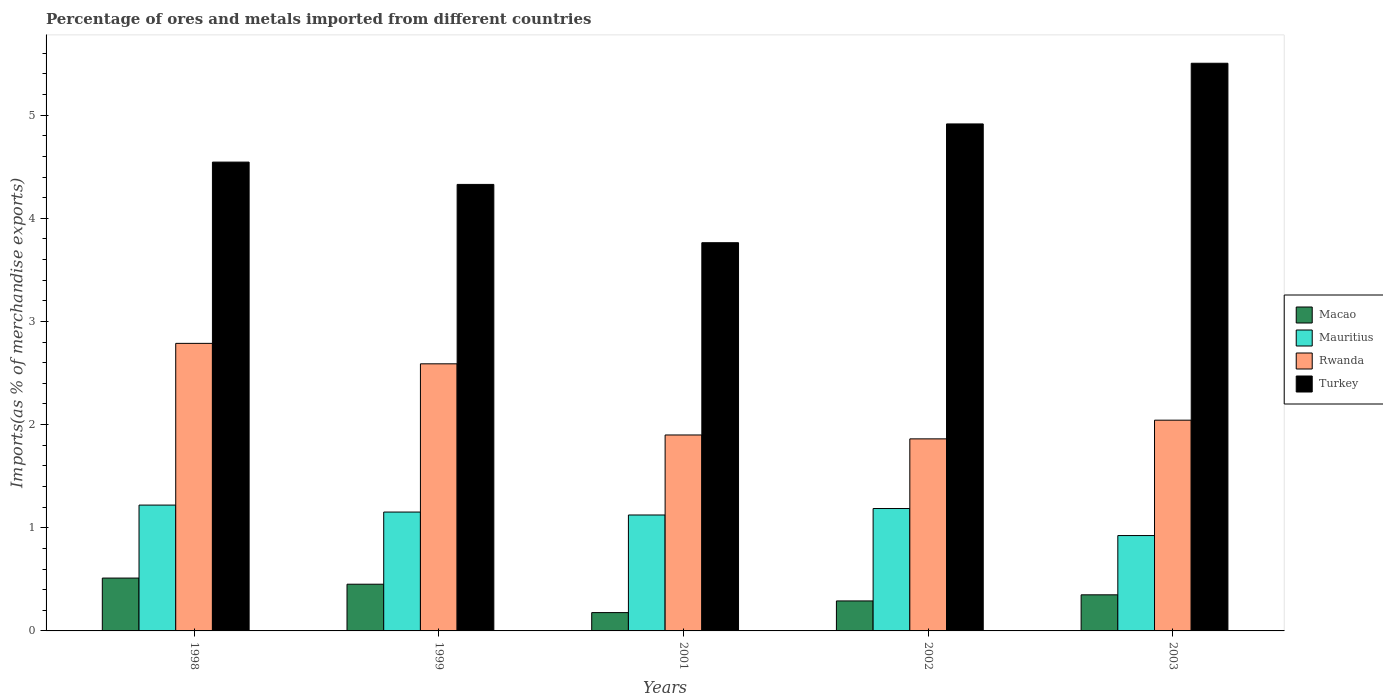How many groups of bars are there?
Offer a very short reply. 5. Are the number of bars per tick equal to the number of legend labels?
Offer a very short reply. Yes. Are the number of bars on each tick of the X-axis equal?
Give a very brief answer. Yes. How many bars are there on the 5th tick from the right?
Your response must be concise. 4. What is the label of the 5th group of bars from the left?
Your answer should be very brief. 2003. In how many cases, is the number of bars for a given year not equal to the number of legend labels?
Your answer should be compact. 0. What is the percentage of imports to different countries in Rwanda in 1999?
Your response must be concise. 2.59. Across all years, what is the maximum percentage of imports to different countries in Rwanda?
Keep it short and to the point. 2.79. Across all years, what is the minimum percentage of imports to different countries in Macao?
Provide a short and direct response. 0.18. In which year was the percentage of imports to different countries in Turkey minimum?
Give a very brief answer. 2001. What is the total percentage of imports to different countries in Mauritius in the graph?
Offer a very short reply. 5.61. What is the difference between the percentage of imports to different countries in Mauritius in 1998 and that in 2003?
Provide a short and direct response. 0.3. What is the difference between the percentage of imports to different countries in Macao in 2001 and the percentage of imports to different countries in Mauritius in 1999?
Your answer should be very brief. -0.97. What is the average percentage of imports to different countries in Macao per year?
Ensure brevity in your answer.  0.36. In the year 2003, what is the difference between the percentage of imports to different countries in Rwanda and percentage of imports to different countries in Mauritius?
Your answer should be compact. 1.12. In how many years, is the percentage of imports to different countries in Mauritius greater than 3.6 %?
Provide a succinct answer. 0. What is the ratio of the percentage of imports to different countries in Macao in 1998 to that in 2002?
Ensure brevity in your answer.  1.76. Is the percentage of imports to different countries in Mauritius in 1998 less than that in 2003?
Offer a very short reply. No. What is the difference between the highest and the second highest percentage of imports to different countries in Macao?
Make the answer very short. 0.06. What is the difference between the highest and the lowest percentage of imports to different countries in Mauritius?
Provide a short and direct response. 0.3. In how many years, is the percentage of imports to different countries in Turkey greater than the average percentage of imports to different countries in Turkey taken over all years?
Offer a terse response. 2. Is the sum of the percentage of imports to different countries in Turkey in 1998 and 2001 greater than the maximum percentage of imports to different countries in Rwanda across all years?
Offer a very short reply. Yes. What does the 4th bar from the left in 2001 represents?
Provide a short and direct response. Turkey. Is it the case that in every year, the sum of the percentage of imports to different countries in Turkey and percentage of imports to different countries in Macao is greater than the percentage of imports to different countries in Rwanda?
Provide a short and direct response. Yes. How many bars are there?
Your answer should be very brief. 20. How many legend labels are there?
Offer a very short reply. 4. How are the legend labels stacked?
Keep it short and to the point. Vertical. What is the title of the graph?
Your response must be concise. Percentage of ores and metals imported from different countries. What is the label or title of the X-axis?
Offer a very short reply. Years. What is the label or title of the Y-axis?
Offer a terse response. Imports(as % of merchandise exports). What is the Imports(as % of merchandise exports) of Macao in 1998?
Your answer should be very brief. 0.51. What is the Imports(as % of merchandise exports) in Mauritius in 1998?
Provide a succinct answer. 1.22. What is the Imports(as % of merchandise exports) of Rwanda in 1998?
Offer a terse response. 2.79. What is the Imports(as % of merchandise exports) in Turkey in 1998?
Your response must be concise. 4.54. What is the Imports(as % of merchandise exports) of Macao in 1999?
Keep it short and to the point. 0.45. What is the Imports(as % of merchandise exports) in Mauritius in 1999?
Make the answer very short. 1.15. What is the Imports(as % of merchandise exports) in Rwanda in 1999?
Your answer should be compact. 2.59. What is the Imports(as % of merchandise exports) in Turkey in 1999?
Offer a terse response. 4.33. What is the Imports(as % of merchandise exports) in Macao in 2001?
Provide a short and direct response. 0.18. What is the Imports(as % of merchandise exports) of Mauritius in 2001?
Give a very brief answer. 1.12. What is the Imports(as % of merchandise exports) of Rwanda in 2001?
Give a very brief answer. 1.9. What is the Imports(as % of merchandise exports) in Turkey in 2001?
Offer a terse response. 3.76. What is the Imports(as % of merchandise exports) of Macao in 2002?
Make the answer very short. 0.29. What is the Imports(as % of merchandise exports) of Mauritius in 2002?
Your answer should be compact. 1.19. What is the Imports(as % of merchandise exports) in Rwanda in 2002?
Ensure brevity in your answer.  1.86. What is the Imports(as % of merchandise exports) in Turkey in 2002?
Give a very brief answer. 4.91. What is the Imports(as % of merchandise exports) in Macao in 2003?
Ensure brevity in your answer.  0.35. What is the Imports(as % of merchandise exports) in Mauritius in 2003?
Keep it short and to the point. 0.92. What is the Imports(as % of merchandise exports) of Rwanda in 2003?
Offer a terse response. 2.04. What is the Imports(as % of merchandise exports) of Turkey in 2003?
Your answer should be compact. 5.5. Across all years, what is the maximum Imports(as % of merchandise exports) in Macao?
Provide a short and direct response. 0.51. Across all years, what is the maximum Imports(as % of merchandise exports) of Mauritius?
Give a very brief answer. 1.22. Across all years, what is the maximum Imports(as % of merchandise exports) in Rwanda?
Provide a succinct answer. 2.79. Across all years, what is the maximum Imports(as % of merchandise exports) of Turkey?
Make the answer very short. 5.5. Across all years, what is the minimum Imports(as % of merchandise exports) of Macao?
Your answer should be very brief. 0.18. Across all years, what is the minimum Imports(as % of merchandise exports) in Mauritius?
Make the answer very short. 0.92. Across all years, what is the minimum Imports(as % of merchandise exports) of Rwanda?
Give a very brief answer. 1.86. Across all years, what is the minimum Imports(as % of merchandise exports) in Turkey?
Offer a terse response. 3.76. What is the total Imports(as % of merchandise exports) in Macao in the graph?
Keep it short and to the point. 1.78. What is the total Imports(as % of merchandise exports) of Mauritius in the graph?
Offer a very short reply. 5.61. What is the total Imports(as % of merchandise exports) of Rwanda in the graph?
Keep it short and to the point. 11.18. What is the total Imports(as % of merchandise exports) in Turkey in the graph?
Provide a succinct answer. 23.05. What is the difference between the Imports(as % of merchandise exports) of Macao in 1998 and that in 1999?
Provide a succinct answer. 0.06. What is the difference between the Imports(as % of merchandise exports) of Mauritius in 1998 and that in 1999?
Give a very brief answer. 0.07. What is the difference between the Imports(as % of merchandise exports) of Rwanda in 1998 and that in 1999?
Offer a terse response. 0.2. What is the difference between the Imports(as % of merchandise exports) of Turkey in 1998 and that in 1999?
Offer a terse response. 0.22. What is the difference between the Imports(as % of merchandise exports) of Macao in 1998 and that in 2001?
Keep it short and to the point. 0.33. What is the difference between the Imports(as % of merchandise exports) in Mauritius in 1998 and that in 2001?
Make the answer very short. 0.1. What is the difference between the Imports(as % of merchandise exports) in Rwanda in 1998 and that in 2001?
Give a very brief answer. 0.89. What is the difference between the Imports(as % of merchandise exports) of Turkey in 1998 and that in 2001?
Keep it short and to the point. 0.78. What is the difference between the Imports(as % of merchandise exports) of Macao in 1998 and that in 2002?
Make the answer very short. 0.22. What is the difference between the Imports(as % of merchandise exports) of Mauritius in 1998 and that in 2002?
Keep it short and to the point. 0.03. What is the difference between the Imports(as % of merchandise exports) in Rwanda in 1998 and that in 2002?
Ensure brevity in your answer.  0.93. What is the difference between the Imports(as % of merchandise exports) in Turkey in 1998 and that in 2002?
Your response must be concise. -0.37. What is the difference between the Imports(as % of merchandise exports) in Macao in 1998 and that in 2003?
Your answer should be compact. 0.16. What is the difference between the Imports(as % of merchandise exports) of Mauritius in 1998 and that in 2003?
Your response must be concise. 0.3. What is the difference between the Imports(as % of merchandise exports) in Rwanda in 1998 and that in 2003?
Your answer should be compact. 0.74. What is the difference between the Imports(as % of merchandise exports) in Turkey in 1998 and that in 2003?
Provide a short and direct response. -0.96. What is the difference between the Imports(as % of merchandise exports) in Macao in 1999 and that in 2001?
Offer a terse response. 0.28. What is the difference between the Imports(as % of merchandise exports) in Mauritius in 1999 and that in 2001?
Give a very brief answer. 0.03. What is the difference between the Imports(as % of merchandise exports) of Rwanda in 1999 and that in 2001?
Your answer should be compact. 0.69. What is the difference between the Imports(as % of merchandise exports) in Turkey in 1999 and that in 2001?
Provide a succinct answer. 0.57. What is the difference between the Imports(as % of merchandise exports) of Macao in 1999 and that in 2002?
Your answer should be very brief. 0.16. What is the difference between the Imports(as % of merchandise exports) in Mauritius in 1999 and that in 2002?
Your answer should be very brief. -0.03. What is the difference between the Imports(as % of merchandise exports) in Rwanda in 1999 and that in 2002?
Keep it short and to the point. 0.73. What is the difference between the Imports(as % of merchandise exports) in Turkey in 1999 and that in 2002?
Provide a short and direct response. -0.59. What is the difference between the Imports(as % of merchandise exports) in Macao in 1999 and that in 2003?
Your answer should be compact. 0.1. What is the difference between the Imports(as % of merchandise exports) of Mauritius in 1999 and that in 2003?
Your answer should be compact. 0.23. What is the difference between the Imports(as % of merchandise exports) of Rwanda in 1999 and that in 2003?
Make the answer very short. 0.55. What is the difference between the Imports(as % of merchandise exports) in Turkey in 1999 and that in 2003?
Your answer should be compact. -1.17. What is the difference between the Imports(as % of merchandise exports) of Macao in 2001 and that in 2002?
Offer a very short reply. -0.11. What is the difference between the Imports(as % of merchandise exports) of Mauritius in 2001 and that in 2002?
Make the answer very short. -0.06. What is the difference between the Imports(as % of merchandise exports) in Rwanda in 2001 and that in 2002?
Your answer should be very brief. 0.04. What is the difference between the Imports(as % of merchandise exports) in Turkey in 2001 and that in 2002?
Your answer should be very brief. -1.15. What is the difference between the Imports(as % of merchandise exports) of Macao in 2001 and that in 2003?
Give a very brief answer. -0.17. What is the difference between the Imports(as % of merchandise exports) in Mauritius in 2001 and that in 2003?
Give a very brief answer. 0.2. What is the difference between the Imports(as % of merchandise exports) of Rwanda in 2001 and that in 2003?
Make the answer very short. -0.14. What is the difference between the Imports(as % of merchandise exports) in Turkey in 2001 and that in 2003?
Your answer should be very brief. -1.74. What is the difference between the Imports(as % of merchandise exports) in Macao in 2002 and that in 2003?
Your response must be concise. -0.06. What is the difference between the Imports(as % of merchandise exports) of Mauritius in 2002 and that in 2003?
Keep it short and to the point. 0.26. What is the difference between the Imports(as % of merchandise exports) of Rwanda in 2002 and that in 2003?
Offer a terse response. -0.18. What is the difference between the Imports(as % of merchandise exports) of Turkey in 2002 and that in 2003?
Give a very brief answer. -0.59. What is the difference between the Imports(as % of merchandise exports) of Macao in 1998 and the Imports(as % of merchandise exports) of Mauritius in 1999?
Offer a very short reply. -0.64. What is the difference between the Imports(as % of merchandise exports) in Macao in 1998 and the Imports(as % of merchandise exports) in Rwanda in 1999?
Make the answer very short. -2.08. What is the difference between the Imports(as % of merchandise exports) of Macao in 1998 and the Imports(as % of merchandise exports) of Turkey in 1999?
Keep it short and to the point. -3.82. What is the difference between the Imports(as % of merchandise exports) of Mauritius in 1998 and the Imports(as % of merchandise exports) of Rwanda in 1999?
Provide a short and direct response. -1.37. What is the difference between the Imports(as % of merchandise exports) of Mauritius in 1998 and the Imports(as % of merchandise exports) of Turkey in 1999?
Provide a short and direct response. -3.11. What is the difference between the Imports(as % of merchandise exports) of Rwanda in 1998 and the Imports(as % of merchandise exports) of Turkey in 1999?
Offer a very short reply. -1.54. What is the difference between the Imports(as % of merchandise exports) in Macao in 1998 and the Imports(as % of merchandise exports) in Mauritius in 2001?
Offer a very short reply. -0.61. What is the difference between the Imports(as % of merchandise exports) of Macao in 1998 and the Imports(as % of merchandise exports) of Rwanda in 2001?
Provide a succinct answer. -1.39. What is the difference between the Imports(as % of merchandise exports) of Macao in 1998 and the Imports(as % of merchandise exports) of Turkey in 2001?
Make the answer very short. -3.25. What is the difference between the Imports(as % of merchandise exports) of Mauritius in 1998 and the Imports(as % of merchandise exports) of Rwanda in 2001?
Offer a terse response. -0.68. What is the difference between the Imports(as % of merchandise exports) in Mauritius in 1998 and the Imports(as % of merchandise exports) in Turkey in 2001?
Give a very brief answer. -2.54. What is the difference between the Imports(as % of merchandise exports) of Rwanda in 1998 and the Imports(as % of merchandise exports) of Turkey in 2001?
Provide a succinct answer. -0.98. What is the difference between the Imports(as % of merchandise exports) of Macao in 1998 and the Imports(as % of merchandise exports) of Mauritius in 2002?
Give a very brief answer. -0.67. What is the difference between the Imports(as % of merchandise exports) of Macao in 1998 and the Imports(as % of merchandise exports) of Rwanda in 2002?
Give a very brief answer. -1.35. What is the difference between the Imports(as % of merchandise exports) of Macao in 1998 and the Imports(as % of merchandise exports) of Turkey in 2002?
Offer a terse response. -4.4. What is the difference between the Imports(as % of merchandise exports) of Mauritius in 1998 and the Imports(as % of merchandise exports) of Rwanda in 2002?
Provide a succinct answer. -0.64. What is the difference between the Imports(as % of merchandise exports) in Mauritius in 1998 and the Imports(as % of merchandise exports) in Turkey in 2002?
Your response must be concise. -3.69. What is the difference between the Imports(as % of merchandise exports) of Rwanda in 1998 and the Imports(as % of merchandise exports) of Turkey in 2002?
Offer a terse response. -2.13. What is the difference between the Imports(as % of merchandise exports) of Macao in 1998 and the Imports(as % of merchandise exports) of Mauritius in 2003?
Give a very brief answer. -0.41. What is the difference between the Imports(as % of merchandise exports) of Macao in 1998 and the Imports(as % of merchandise exports) of Rwanda in 2003?
Your response must be concise. -1.53. What is the difference between the Imports(as % of merchandise exports) in Macao in 1998 and the Imports(as % of merchandise exports) in Turkey in 2003?
Give a very brief answer. -4.99. What is the difference between the Imports(as % of merchandise exports) in Mauritius in 1998 and the Imports(as % of merchandise exports) in Rwanda in 2003?
Provide a succinct answer. -0.82. What is the difference between the Imports(as % of merchandise exports) in Mauritius in 1998 and the Imports(as % of merchandise exports) in Turkey in 2003?
Your response must be concise. -4.28. What is the difference between the Imports(as % of merchandise exports) in Rwanda in 1998 and the Imports(as % of merchandise exports) in Turkey in 2003?
Offer a very short reply. -2.72. What is the difference between the Imports(as % of merchandise exports) of Macao in 1999 and the Imports(as % of merchandise exports) of Mauritius in 2001?
Offer a terse response. -0.67. What is the difference between the Imports(as % of merchandise exports) in Macao in 1999 and the Imports(as % of merchandise exports) in Rwanda in 2001?
Provide a succinct answer. -1.45. What is the difference between the Imports(as % of merchandise exports) in Macao in 1999 and the Imports(as % of merchandise exports) in Turkey in 2001?
Provide a succinct answer. -3.31. What is the difference between the Imports(as % of merchandise exports) in Mauritius in 1999 and the Imports(as % of merchandise exports) in Rwanda in 2001?
Provide a short and direct response. -0.75. What is the difference between the Imports(as % of merchandise exports) in Mauritius in 1999 and the Imports(as % of merchandise exports) in Turkey in 2001?
Your answer should be very brief. -2.61. What is the difference between the Imports(as % of merchandise exports) of Rwanda in 1999 and the Imports(as % of merchandise exports) of Turkey in 2001?
Give a very brief answer. -1.17. What is the difference between the Imports(as % of merchandise exports) in Macao in 1999 and the Imports(as % of merchandise exports) in Mauritius in 2002?
Provide a succinct answer. -0.73. What is the difference between the Imports(as % of merchandise exports) in Macao in 1999 and the Imports(as % of merchandise exports) in Rwanda in 2002?
Ensure brevity in your answer.  -1.41. What is the difference between the Imports(as % of merchandise exports) of Macao in 1999 and the Imports(as % of merchandise exports) of Turkey in 2002?
Offer a terse response. -4.46. What is the difference between the Imports(as % of merchandise exports) in Mauritius in 1999 and the Imports(as % of merchandise exports) in Rwanda in 2002?
Provide a succinct answer. -0.71. What is the difference between the Imports(as % of merchandise exports) in Mauritius in 1999 and the Imports(as % of merchandise exports) in Turkey in 2002?
Make the answer very short. -3.76. What is the difference between the Imports(as % of merchandise exports) in Rwanda in 1999 and the Imports(as % of merchandise exports) in Turkey in 2002?
Provide a short and direct response. -2.33. What is the difference between the Imports(as % of merchandise exports) in Macao in 1999 and the Imports(as % of merchandise exports) in Mauritius in 2003?
Offer a very short reply. -0.47. What is the difference between the Imports(as % of merchandise exports) of Macao in 1999 and the Imports(as % of merchandise exports) of Rwanda in 2003?
Provide a succinct answer. -1.59. What is the difference between the Imports(as % of merchandise exports) of Macao in 1999 and the Imports(as % of merchandise exports) of Turkey in 2003?
Your answer should be compact. -5.05. What is the difference between the Imports(as % of merchandise exports) in Mauritius in 1999 and the Imports(as % of merchandise exports) in Rwanda in 2003?
Offer a very short reply. -0.89. What is the difference between the Imports(as % of merchandise exports) of Mauritius in 1999 and the Imports(as % of merchandise exports) of Turkey in 2003?
Your answer should be very brief. -4.35. What is the difference between the Imports(as % of merchandise exports) of Rwanda in 1999 and the Imports(as % of merchandise exports) of Turkey in 2003?
Give a very brief answer. -2.91. What is the difference between the Imports(as % of merchandise exports) in Macao in 2001 and the Imports(as % of merchandise exports) in Mauritius in 2002?
Make the answer very short. -1.01. What is the difference between the Imports(as % of merchandise exports) in Macao in 2001 and the Imports(as % of merchandise exports) in Rwanda in 2002?
Your response must be concise. -1.68. What is the difference between the Imports(as % of merchandise exports) of Macao in 2001 and the Imports(as % of merchandise exports) of Turkey in 2002?
Ensure brevity in your answer.  -4.74. What is the difference between the Imports(as % of merchandise exports) in Mauritius in 2001 and the Imports(as % of merchandise exports) in Rwanda in 2002?
Provide a succinct answer. -0.74. What is the difference between the Imports(as % of merchandise exports) in Mauritius in 2001 and the Imports(as % of merchandise exports) in Turkey in 2002?
Keep it short and to the point. -3.79. What is the difference between the Imports(as % of merchandise exports) in Rwanda in 2001 and the Imports(as % of merchandise exports) in Turkey in 2002?
Provide a short and direct response. -3.02. What is the difference between the Imports(as % of merchandise exports) in Macao in 2001 and the Imports(as % of merchandise exports) in Mauritius in 2003?
Offer a very short reply. -0.75. What is the difference between the Imports(as % of merchandise exports) of Macao in 2001 and the Imports(as % of merchandise exports) of Rwanda in 2003?
Give a very brief answer. -1.87. What is the difference between the Imports(as % of merchandise exports) in Macao in 2001 and the Imports(as % of merchandise exports) in Turkey in 2003?
Your answer should be very brief. -5.33. What is the difference between the Imports(as % of merchandise exports) of Mauritius in 2001 and the Imports(as % of merchandise exports) of Rwanda in 2003?
Your response must be concise. -0.92. What is the difference between the Imports(as % of merchandise exports) of Mauritius in 2001 and the Imports(as % of merchandise exports) of Turkey in 2003?
Give a very brief answer. -4.38. What is the difference between the Imports(as % of merchandise exports) of Rwanda in 2001 and the Imports(as % of merchandise exports) of Turkey in 2003?
Ensure brevity in your answer.  -3.6. What is the difference between the Imports(as % of merchandise exports) in Macao in 2002 and the Imports(as % of merchandise exports) in Mauritius in 2003?
Offer a terse response. -0.63. What is the difference between the Imports(as % of merchandise exports) in Macao in 2002 and the Imports(as % of merchandise exports) in Rwanda in 2003?
Ensure brevity in your answer.  -1.75. What is the difference between the Imports(as % of merchandise exports) in Macao in 2002 and the Imports(as % of merchandise exports) in Turkey in 2003?
Give a very brief answer. -5.21. What is the difference between the Imports(as % of merchandise exports) in Mauritius in 2002 and the Imports(as % of merchandise exports) in Rwanda in 2003?
Make the answer very short. -0.86. What is the difference between the Imports(as % of merchandise exports) in Mauritius in 2002 and the Imports(as % of merchandise exports) in Turkey in 2003?
Offer a terse response. -4.32. What is the difference between the Imports(as % of merchandise exports) of Rwanda in 2002 and the Imports(as % of merchandise exports) of Turkey in 2003?
Your answer should be compact. -3.64. What is the average Imports(as % of merchandise exports) in Macao per year?
Make the answer very short. 0.36. What is the average Imports(as % of merchandise exports) of Mauritius per year?
Give a very brief answer. 1.12. What is the average Imports(as % of merchandise exports) of Rwanda per year?
Offer a very short reply. 2.24. What is the average Imports(as % of merchandise exports) in Turkey per year?
Your response must be concise. 4.61. In the year 1998, what is the difference between the Imports(as % of merchandise exports) in Macao and Imports(as % of merchandise exports) in Mauritius?
Offer a very short reply. -0.71. In the year 1998, what is the difference between the Imports(as % of merchandise exports) of Macao and Imports(as % of merchandise exports) of Rwanda?
Your response must be concise. -2.28. In the year 1998, what is the difference between the Imports(as % of merchandise exports) of Macao and Imports(as % of merchandise exports) of Turkey?
Offer a terse response. -4.03. In the year 1998, what is the difference between the Imports(as % of merchandise exports) of Mauritius and Imports(as % of merchandise exports) of Rwanda?
Provide a succinct answer. -1.57. In the year 1998, what is the difference between the Imports(as % of merchandise exports) of Mauritius and Imports(as % of merchandise exports) of Turkey?
Keep it short and to the point. -3.32. In the year 1998, what is the difference between the Imports(as % of merchandise exports) of Rwanda and Imports(as % of merchandise exports) of Turkey?
Ensure brevity in your answer.  -1.76. In the year 1999, what is the difference between the Imports(as % of merchandise exports) in Macao and Imports(as % of merchandise exports) in Mauritius?
Provide a short and direct response. -0.7. In the year 1999, what is the difference between the Imports(as % of merchandise exports) of Macao and Imports(as % of merchandise exports) of Rwanda?
Make the answer very short. -2.14. In the year 1999, what is the difference between the Imports(as % of merchandise exports) in Macao and Imports(as % of merchandise exports) in Turkey?
Your answer should be very brief. -3.88. In the year 1999, what is the difference between the Imports(as % of merchandise exports) in Mauritius and Imports(as % of merchandise exports) in Rwanda?
Your response must be concise. -1.44. In the year 1999, what is the difference between the Imports(as % of merchandise exports) of Mauritius and Imports(as % of merchandise exports) of Turkey?
Give a very brief answer. -3.18. In the year 1999, what is the difference between the Imports(as % of merchandise exports) of Rwanda and Imports(as % of merchandise exports) of Turkey?
Give a very brief answer. -1.74. In the year 2001, what is the difference between the Imports(as % of merchandise exports) in Macao and Imports(as % of merchandise exports) in Mauritius?
Ensure brevity in your answer.  -0.95. In the year 2001, what is the difference between the Imports(as % of merchandise exports) in Macao and Imports(as % of merchandise exports) in Rwanda?
Provide a short and direct response. -1.72. In the year 2001, what is the difference between the Imports(as % of merchandise exports) of Macao and Imports(as % of merchandise exports) of Turkey?
Provide a short and direct response. -3.59. In the year 2001, what is the difference between the Imports(as % of merchandise exports) of Mauritius and Imports(as % of merchandise exports) of Rwanda?
Provide a succinct answer. -0.78. In the year 2001, what is the difference between the Imports(as % of merchandise exports) of Mauritius and Imports(as % of merchandise exports) of Turkey?
Make the answer very short. -2.64. In the year 2001, what is the difference between the Imports(as % of merchandise exports) of Rwanda and Imports(as % of merchandise exports) of Turkey?
Offer a terse response. -1.86. In the year 2002, what is the difference between the Imports(as % of merchandise exports) of Macao and Imports(as % of merchandise exports) of Mauritius?
Offer a terse response. -0.9. In the year 2002, what is the difference between the Imports(as % of merchandise exports) of Macao and Imports(as % of merchandise exports) of Rwanda?
Your answer should be very brief. -1.57. In the year 2002, what is the difference between the Imports(as % of merchandise exports) of Macao and Imports(as % of merchandise exports) of Turkey?
Keep it short and to the point. -4.62. In the year 2002, what is the difference between the Imports(as % of merchandise exports) of Mauritius and Imports(as % of merchandise exports) of Rwanda?
Make the answer very short. -0.68. In the year 2002, what is the difference between the Imports(as % of merchandise exports) in Mauritius and Imports(as % of merchandise exports) in Turkey?
Your answer should be very brief. -3.73. In the year 2002, what is the difference between the Imports(as % of merchandise exports) of Rwanda and Imports(as % of merchandise exports) of Turkey?
Your answer should be very brief. -3.05. In the year 2003, what is the difference between the Imports(as % of merchandise exports) of Macao and Imports(as % of merchandise exports) of Mauritius?
Give a very brief answer. -0.57. In the year 2003, what is the difference between the Imports(as % of merchandise exports) of Macao and Imports(as % of merchandise exports) of Rwanda?
Your response must be concise. -1.69. In the year 2003, what is the difference between the Imports(as % of merchandise exports) of Macao and Imports(as % of merchandise exports) of Turkey?
Make the answer very short. -5.15. In the year 2003, what is the difference between the Imports(as % of merchandise exports) of Mauritius and Imports(as % of merchandise exports) of Rwanda?
Ensure brevity in your answer.  -1.12. In the year 2003, what is the difference between the Imports(as % of merchandise exports) in Mauritius and Imports(as % of merchandise exports) in Turkey?
Make the answer very short. -4.58. In the year 2003, what is the difference between the Imports(as % of merchandise exports) in Rwanda and Imports(as % of merchandise exports) in Turkey?
Make the answer very short. -3.46. What is the ratio of the Imports(as % of merchandise exports) of Macao in 1998 to that in 1999?
Your answer should be compact. 1.13. What is the ratio of the Imports(as % of merchandise exports) in Mauritius in 1998 to that in 1999?
Keep it short and to the point. 1.06. What is the ratio of the Imports(as % of merchandise exports) of Rwanda in 1998 to that in 1999?
Provide a succinct answer. 1.08. What is the ratio of the Imports(as % of merchandise exports) of Macao in 1998 to that in 2001?
Provide a short and direct response. 2.89. What is the ratio of the Imports(as % of merchandise exports) in Mauritius in 1998 to that in 2001?
Your answer should be compact. 1.09. What is the ratio of the Imports(as % of merchandise exports) of Rwanda in 1998 to that in 2001?
Your answer should be very brief. 1.47. What is the ratio of the Imports(as % of merchandise exports) in Turkey in 1998 to that in 2001?
Give a very brief answer. 1.21. What is the ratio of the Imports(as % of merchandise exports) in Macao in 1998 to that in 2002?
Keep it short and to the point. 1.76. What is the ratio of the Imports(as % of merchandise exports) of Mauritius in 1998 to that in 2002?
Keep it short and to the point. 1.03. What is the ratio of the Imports(as % of merchandise exports) of Rwanda in 1998 to that in 2002?
Make the answer very short. 1.5. What is the ratio of the Imports(as % of merchandise exports) in Turkey in 1998 to that in 2002?
Your answer should be compact. 0.92. What is the ratio of the Imports(as % of merchandise exports) of Macao in 1998 to that in 2003?
Your answer should be very brief. 1.46. What is the ratio of the Imports(as % of merchandise exports) of Mauritius in 1998 to that in 2003?
Give a very brief answer. 1.32. What is the ratio of the Imports(as % of merchandise exports) of Rwanda in 1998 to that in 2003?
Provide a short and direct response. 1.36. What is the ratio of the Imports(as % of merchandise exports) of Turkey in 1998 to that in 2003?
Ensure brevity in your answer.  0.83. What is the ratio of the Imports(as % of merchandise exports) in Macao in 1999 to that in 2001?
Your response must be concise. 2.55. What is the ratio of the Imports(as % of merchandise exports) of Mauritius in 1999 to that in 2001?
Your answer should be very brief. 1.03. What is the ratio of the Imports(as % of merchandise exports) in Rwanda in 1999 to that in 2001?
Give a very brief answer. 1.36. What is the ratio of the Imports(as % of merchandise exports) in Turkey in 1999 to that in 2001?
Your answer should be very brief. 1.15. What is the ratio of the Imports(as % of merchandise exports) of Macao in 1999 to that in 2002?
Provide a succinct answer. 1.56. What is the ratio of the Imports(as % of merchandise exports) in Mauritius in 1999 to that in 2002?
Provide a short and direct response. 0.97. What is the ratio of the Imports(as % of merchandise exports) in Rwanda in 1999 to that in 2002?
Your answer should be compact. 1.39. What is the ratio of the Imports(as % of merchandise exports) in Turkey in 1999 to that in 2002?
Provide a succinct answer. 0.88. What is the ratio of the Imports(as % of merchandise exports) of Macao in 1999 to that in 2003?
Provide a succinct answer. 1.29. What is the ratio of the Imports(as % of merchandise exports) of Mauritius in 1999 to that in 2003?
Keep it short and to the point. 1.25. What is the ratio of the Imports(as % of merchandise exports) of Rwanda in 1999 to that in 2003?
Keep it short and to the point. 1.27. What is the ratio of the Imports(as % of merchandise exports) in Turkey in 1999 to that in 2003?
Provide a short and direct response. 0.79. What is the ratio of the Imports(as % of merchandise exports) of Macao in 2001 to that in 2002?
Your answer should be compact. 0.61. What is the ratio of the Imports(as % of merchandise exports) in Mauritius in 2001 to that in 2002?
Give a very brief answer. 0.95. What is the ratio of the Imports(as % of merchandise exports) in Rwanda in 2001 to that in 2002?
Make the answer very short. 1.02. What is the ratio of the Imports(as % of merchandise exports) of Turkey in 2001 to that in 2002?
Provide a short and direct response. 0.77. What is the ratio of the Imports(as % of merchandise exports) in Macao in 2001 to that in 2003?
Offer a very short reply. 0.51. What is the ratio of the Imports(as % of merchandise exports) in Mauritius in 2001 to that in 2003?
Your response must be concise. 1.22. What is the ratio of the Imports(as % of merchandise exports) in Rwanda in 2001 to that in 2003?
Ensure brevity in your answer.  0.93. What is the ratio of the Imports(as % of merchandise exports) of Turkey in 2001 to that in 2003?
Give a very brief answer. 0.68. What is the ratio of the Imports(as % of merchandise exports) of Macao in 2002 to that in 2003?
Your answer should be very brief. 0.83. What is the ratio of the Imports(as % of merchandise exports) in Mauritius in 2002 to that in 2003?
Your response must be concise. 1.28. What is the ratio of the Imports(as % of merchandise exports) in Rwanda in 2002 to that in 2003?
Keep it short and to the point. 0.91. What is the ratio of the Imports(as % of merchandise exports) in Turkey in 2002 to that in 2003?
Offer a very short reply. 0.89. What is the difference between the highest and the second highest Imports(as % of merchandise exports) of Macao?
Your response must be concise. 0.06. What is the difference between the highest and the second highest Imports(as % of merchandise exports) in Mauritius?
Make the answer very short. 0.03. What is the difference between the highest and the second highest Imports(as % of merchandise exports) of Rwanda?
Your answer should be very brief. 0.2. What is the difference between the highest and the second highest Imports(as % of merchandise exports) in Turkey?
Provide a succinct answer. 0.59. What is the difference between the highest and the lowest Imports(as % of merchandise exports) in Macao?
Keep it short and to the point. 0.33. What is the difference between the highest and the lowest Imports(as % of merchandise exports) of Mauritius?
Offer a terse response. 0.3. What is the difference between the highest and the lowest Imports(as % of merchandise exports) in Rwanda?
Make the answer very short. 0.93. What is the difference between the highest and the lowest Imports(as % of merchandise exports) in Turkey?
Provide a short and direct response. 1.74. 